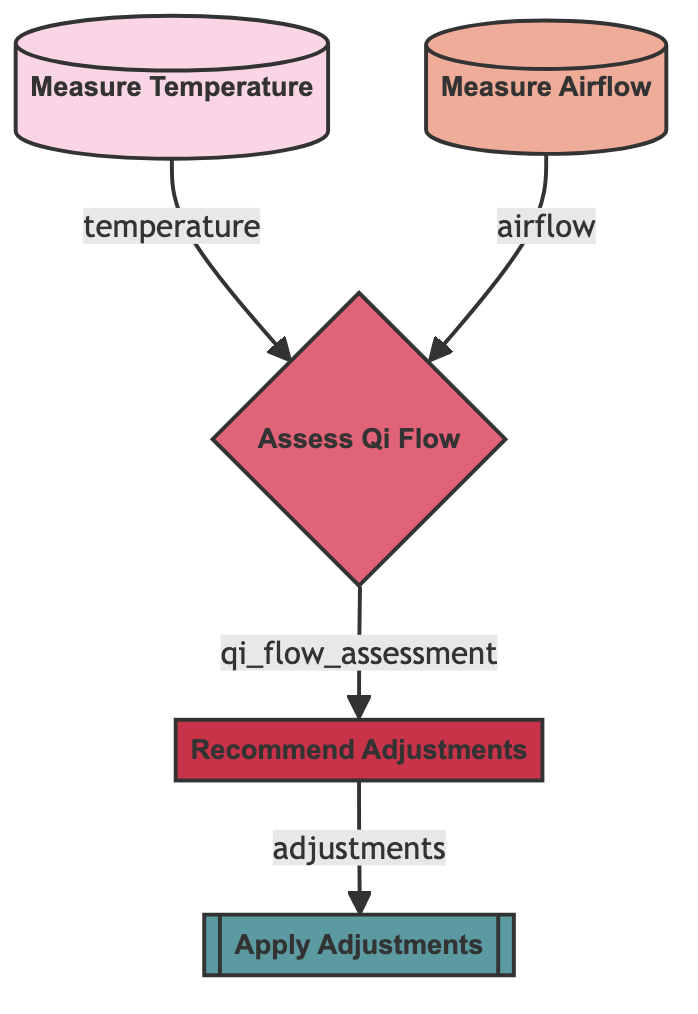What is the first step in the diagram? The first step is "Measure Temperature," which is the initial node before any assessments occur.
Answer: Measure Temperature How many total nodes are present in the diagram? Counting all the unique steps from measuring temperature to applying adjustments, there are five nodes in total.
Answer: Five What is the output of the "measure_airflow" element? The "measure_airflow" element outputs "airflow," which feeds into the assessment stage.
Answer: airflow Which node directly receives outputs from both "measure_temperature" and "measure_airflow"? The node that receives outputs from both measuring elements is "Assess Qi Flow," as it combines temperature and airflow data into its evaluation.
Answer: Assess Qi Flow What actions does the "recommend_adjustments" node lead to? The "recommend_adjustments" node leads to the action of "Apply Adjustments," which is the next step following the recommendations made based on the assessment.
Answer: Apply Adjustments What type of data does the "assess_qi_flow" node require? The "assess_qi_flow" node requires both "temperature" and "airflow" data inputs to carry out its evaluation of Qi flow.
Answer: temperature and airflow How many outputs does the "assess_qi_flow" node produce? The "assess_qi_flow" node produces one output, which is the "qi_flow_assessment," leading to subsequent recommendations.
Answer: one What is one possible adjustment suggested in the "recommend_adjustments" step? The "recommend_adjustments" step may suggest alterations such as changing furniture arrangements or adding plants to improve Qi circulation.
Answer: change furniture arrangement What is the color of the "apply_adjustments" node? The color of the "apply_adjustments" node is represented as #5b9aa0, indicating it distinctively follows the adjustment recommendations.
Answer: #5b9aa0 